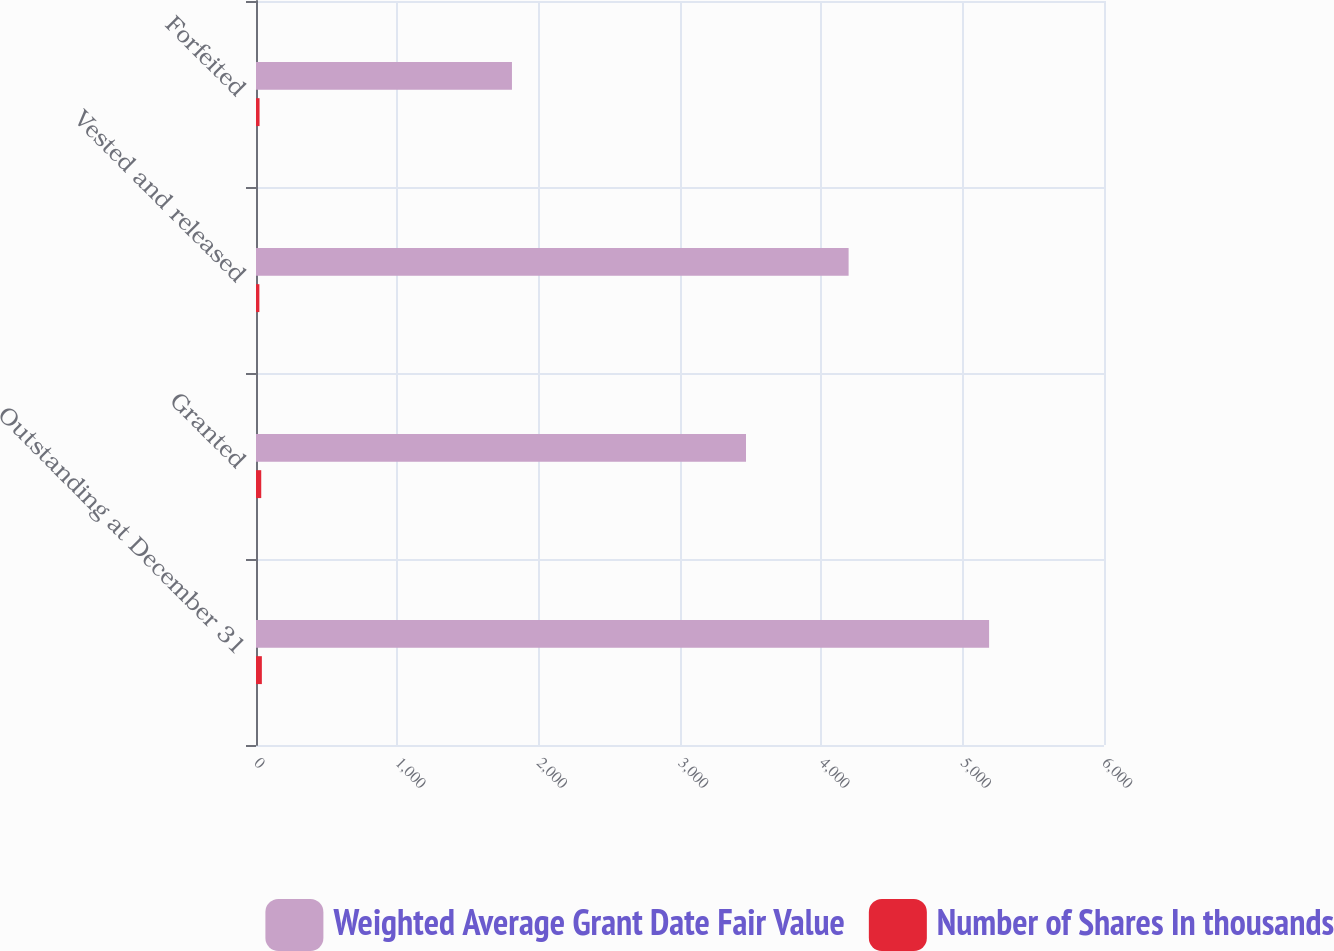Convert chart. <chart><loc_0><loc_0><loc_500><loc_500><stacked_bar_chart><ecel><fcel>Outstanding at December 31<fcel>Granted<fcel>Vested and released<fcel>Forfeited<nl><fcel>Weighted Average Grant Date Fair Value<fcel>5187<fcel>3467<fcel>4193<fcel>1811<nl><fcel>Number of Shares In thousands<fcel>41.48<fcel>37.07<fcel>23.84<fcel>25.1<nl></chart> 